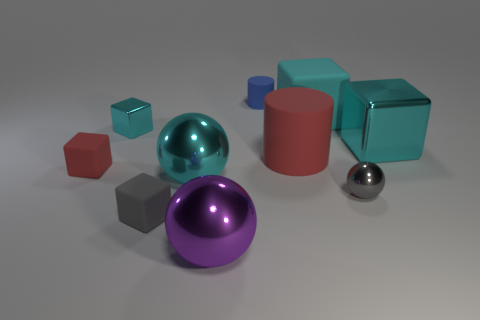How many cyan blocks must be subtracted to get 1 cyan blocks? 2 Subtract all red spheres. How many cyan blocks are left? 3 Subtract all gray blocks. How many blocks are left? 4 Subtract all small gray cubes. How many cubes are left? 4 Subtract all purple blocks. Subtract all yellow balls. How many blocks are left? 5 Subtract all cylinders. How many objects are left? 8 Subtract 0 green balls. How many objects are left? 10 Subtract all matte objects. Subtract all large yellow spheres. How many objects are left? 5 Add 5 matte cylinders. How many matte cylinders are left? 7 Add 2 big red cylinders. How many big red cylinders exist? 3 